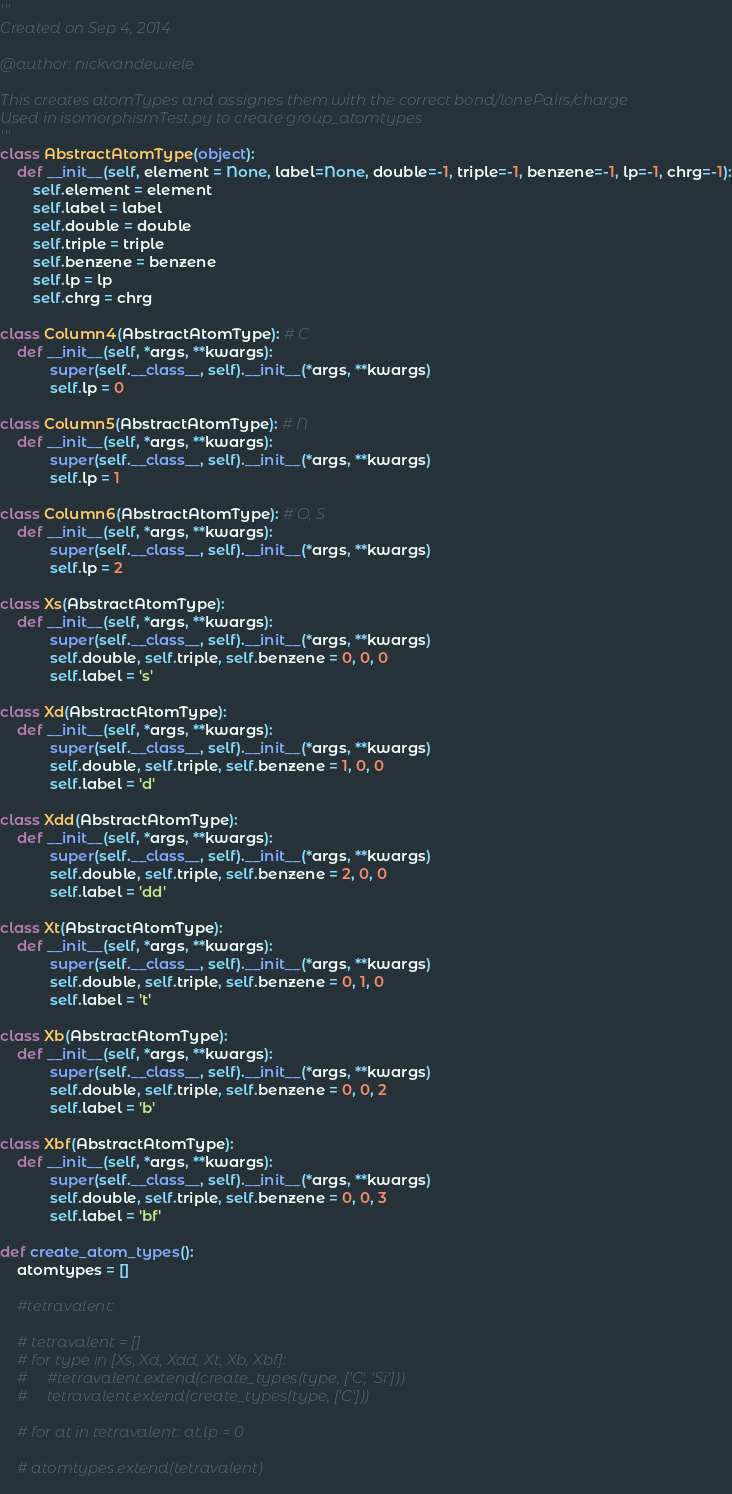Convert code to text. <code><loc_0><loc_0><loc_500><loc_500><_Python_>'''
Created on Sep 4, 2014

@author: nickvandewiele

This creates atomTypes and assignes them with the correct bond/lonePairs/charge
Used in isomorphismTest.py to create group_atomtypes
'''
class AbstractAtomType(object):
    def __init__(self, element = None, label=None, double=-1, triple=-1, benzene=-1, lp=-1, chrg=-1):
        self.element = element
        self.label = label
        self.double = double
        self.triple = triple
        self.benzene = benzene
        self.lp = lp
        self.chrg = chrg

class Column4(AbstractAtomType): # C
    def __init__(self, *args, **kwargs):
            super(self.__class__, self).__init__(*args, **kwargs)
            self.lp = 0
            
class Column5(AbstractAtomType): # N
    def __init__(self, *args, **kwargs):
            super(self.__class__, self).__init__(*args, **kwargs)
            self.lp = 1

class Column6(AbstractAtomType): # O, S
    def __init__(self, *args, **kwargs):
            super(self.__class__, self).__init__(*args, **kwargs)
            self.lp = 2        

class Xs(AbstractAtomType):
    def __init__(self, *args, **kwargs):
            super(self.__class__, self).__init__(*args, **kwargs)
            self.double, self.triple, self.benzene = 0, 0, 0
            self.label = 's'
            
class Xd(AbstractAtomType):
    def __init__(self, *args, **kwargs):
            super(self.__class__, self).__init__(*args, **kwargs)
            self.double, self.triple, self.benzene = 1, 0, 0
            self.label = 'd'
            
class Xdd(AbstractAtomType):
    def __init__(self, *args, **kwargs):
            super(self.__class__, self).__init__(*args, **kwargs)
            self.double, self.triple, self.benzene = 2, 0, 0
            self.label = 'dd'
            
class Xt(AbstractAtomType):
    def __init__(self, *args, **kwargs):
            super(self.__class__, self).__init__(*args, **kwargs)
            self.double, self.triple, self.benzene = 0, 1, 0
            self.label = 't'
                        
class Xb(AbstractAtomType):
    def __init__(self, *args, **kwargs):
            super(self.__class__, self).__init__(*args, **kwargs)
            self.double, self.triple, self.benzene = 0, 0, 2
            self.label = 'b'            

class Xbf(AbstractAtomType):
    def __init__(self, *args, **kwargs):
            super(self.__class__, self).__init__(*args, **kwargs)
            self.double, self.triple, self.benzene = 0, 0, 3
            self.label = 'bf'
                            
def create_atom_types():
    atomtypes = []
    
    #tetravalent:
    
    # tetravalent = []
    # for type in [Xs, Xd, Xdd, Xt, Xb, Xbf]:
    #     #tetravalent.extend(create_types(type, ['C', 'Si']))
    #     tetravalent.extend(create_types(type, ['C']))
    
    # for at in tetravalent: at.lp = 0
    
    # atomtypes.extend(tetravalent)
            </code> 